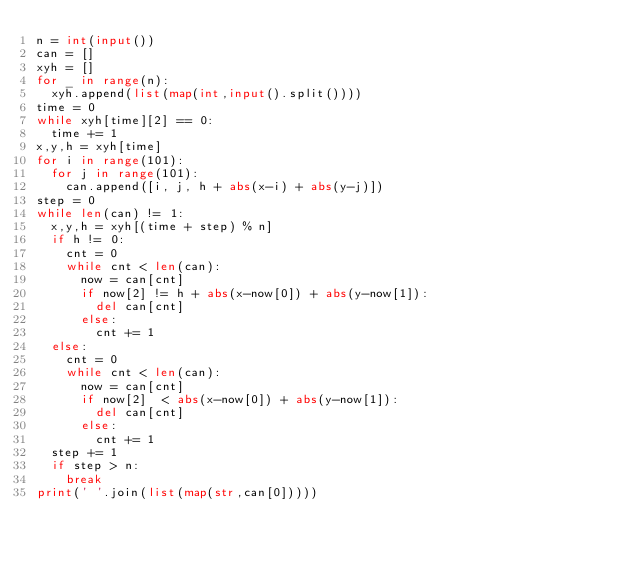<code> <loc_0><loc_0><loc_500><loc_500><_Python_>n = int(input())
can = []
xyh = []
for _ in range(n):
  xyh.append(list(map(int,input().split())))
time = 0
while xyh[time][2] == 0:
  time += 1
x,y,h = xyh[time]
for i in range(101):
  for j in range(101):
    can.append([i, j, h + abs(x-i) + abs(y-j)])
step = 0
while len(can) != 1:
  x,y,h = xyh[(time + step) % n]
  if h != 0:
    cnt = 0
    while cnt < len(can):
      now = can[cnt]
      if now[2] != h + abs(x-now[0]) + abs(y-now[1]):
        del can[cnt]
      else:
        cnt += 1
  else:
    cnt = 0
    while cnt < len(can):
      now = can[cnt]
      if now[2]  < abs(x-now[0]) + abs(y-now[1]):
        del can[cnt]
      else:
        cnt += 1
  step += 1
  if step > n:
    break
print(' '.join(list(map(str,can[0]))))</code> 